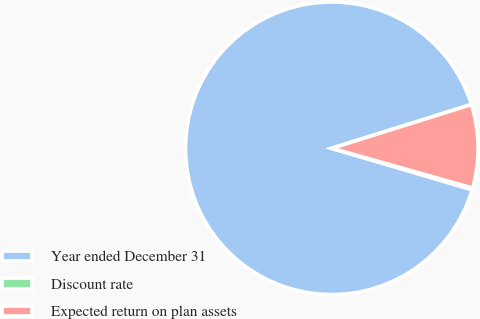<chart> <loc_0><loc_0><loc_500><loc_500><pie_chart><fcel>Year ended December 31<fcel>Discount rate<fcel>Expected return on plan assets<nl><fcel>90.6%<fcel>0.18%<fcel>9.22%<nl></chart> 